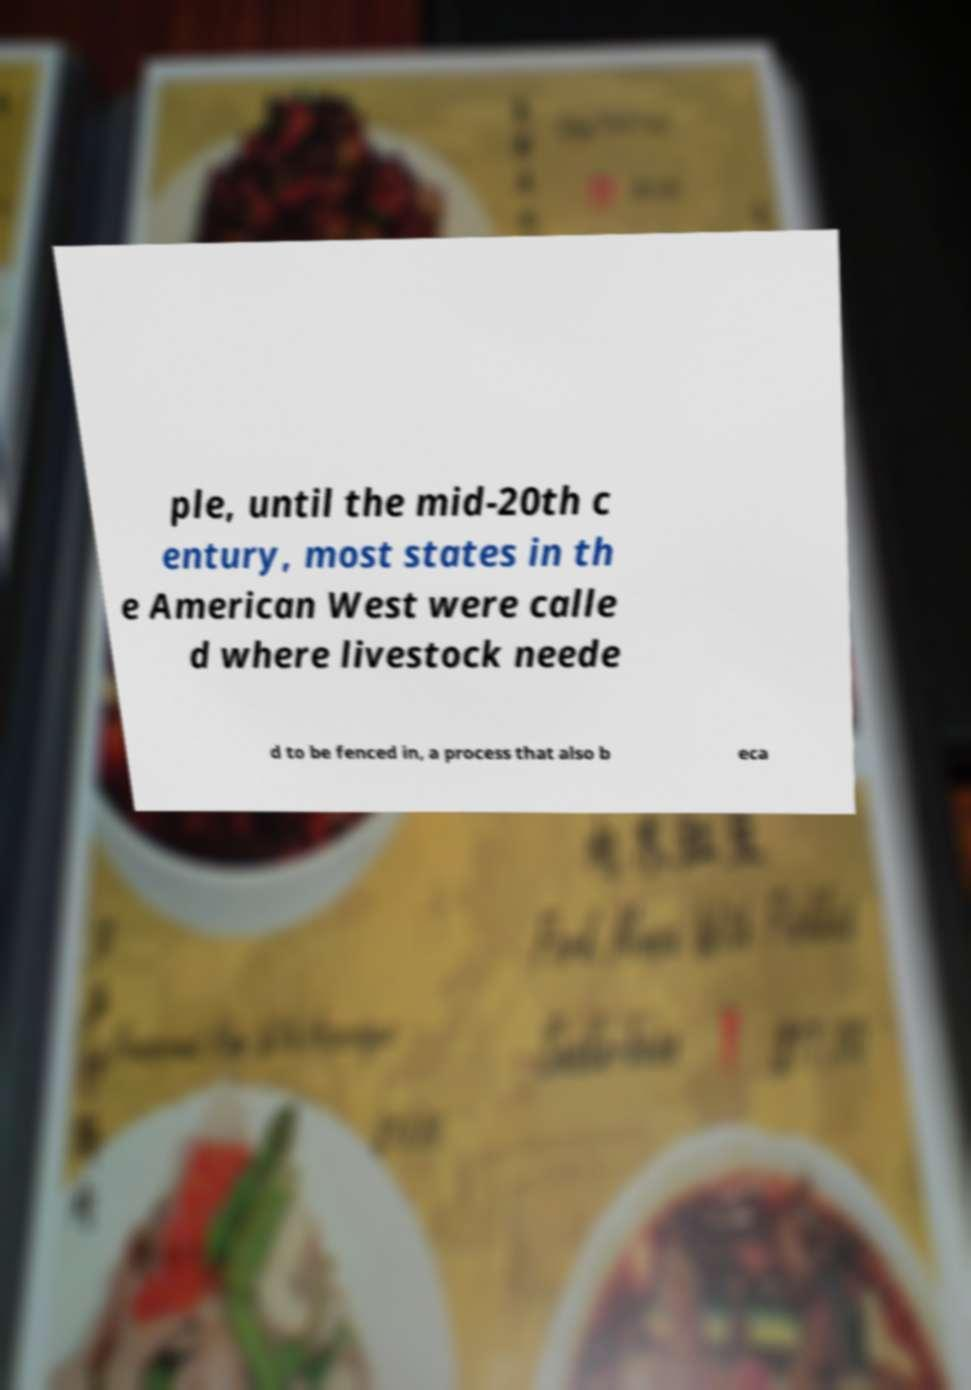Can you read and provide the text displayed in the image?This photo seems to have some interesting text. Can you extract and type it out for me? ple, until the mid-20th c entury, most states in th e American West were calle d where livestock neede d to be fenced in, a process that also b eca 